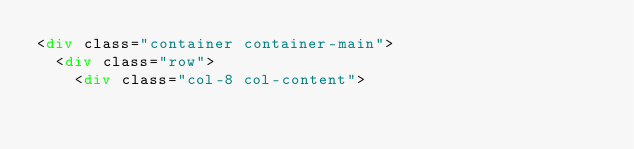Convert code to text. <code><loc_0><loc_0><loc_500><loc_500><_HTML_><div class="container container-main">
	<div class="row">
		<div class="col-8 col-content"></code> 